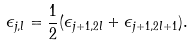Convert formula to latex. <formula><loc_0><loc_0><loc_500><loc_500>\epsilon _ { j , l } = \frac { 1 } { 2 } ( \epsilon _ { j + 1 , 2 l } + \epsilon _ { j + 1 , 2 l + 1 } ) .</formula> 